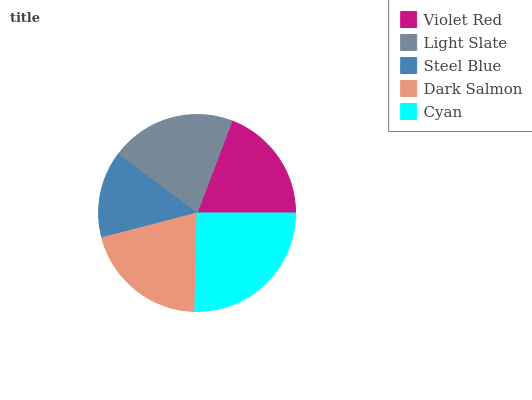Is Steel Blue the minimum?
Answer yes or no. Yes. Is Cyan the maximum?
Answer yes or no. Yes. Is Light Slate the minimum?
Answer yes or no. No. Is Light Slate the maximum?
Answer yes or no. No. Is Light Slate greater than Violet Red?
Answer yes or no. Yes. Is Violet Red less than Light Slate?
Answer yes or no. Yes. Is Violet Red greater than Light Slate?
Answer yes or no. No. Is Light Slate less than Violet Red?
Answer yes or no. No. Is Dark Salmon the high median?
Answer yes or no. Yes. Is Dark Salmon the low median?
Answer yes or no. Yes. Is Violet Red the high median?
Answer yes or no. No. Is Steel Blue the low median?
Answer yes or no. No. 